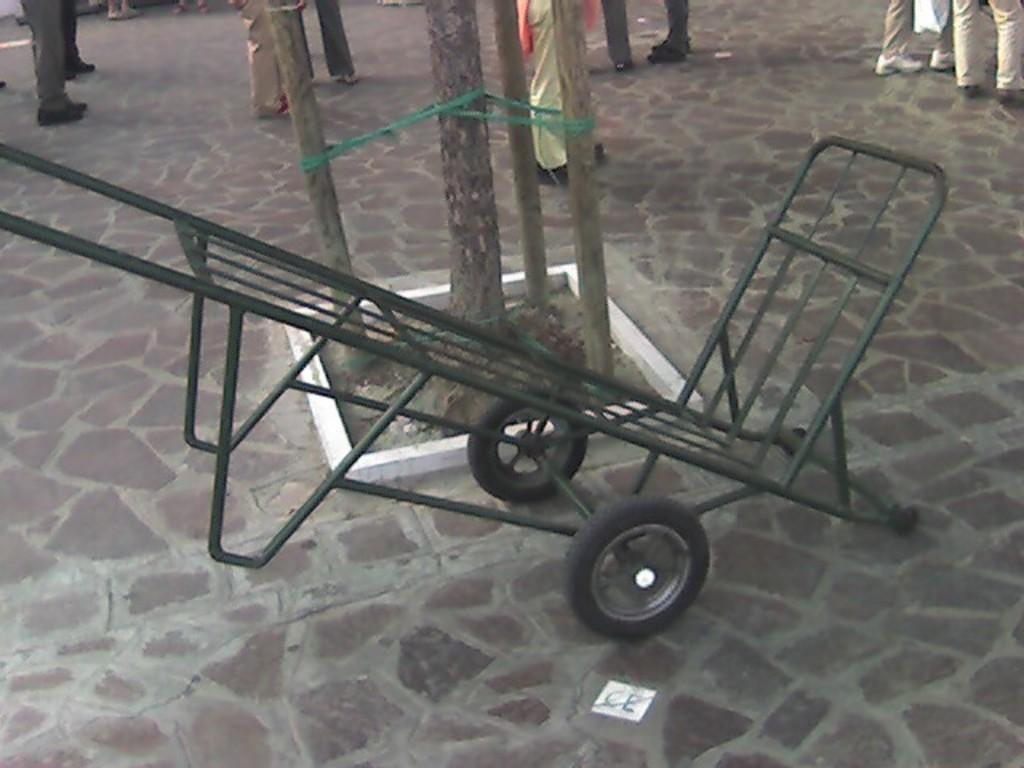What is on the path in the image? There is a trolley and tree trunks on the path in the image. How many people can be seen in the background of the image? Few people are visible in the background of the image. What type of vessel is being carried by the giants in the image? There are no giants or vessels present in the image. 